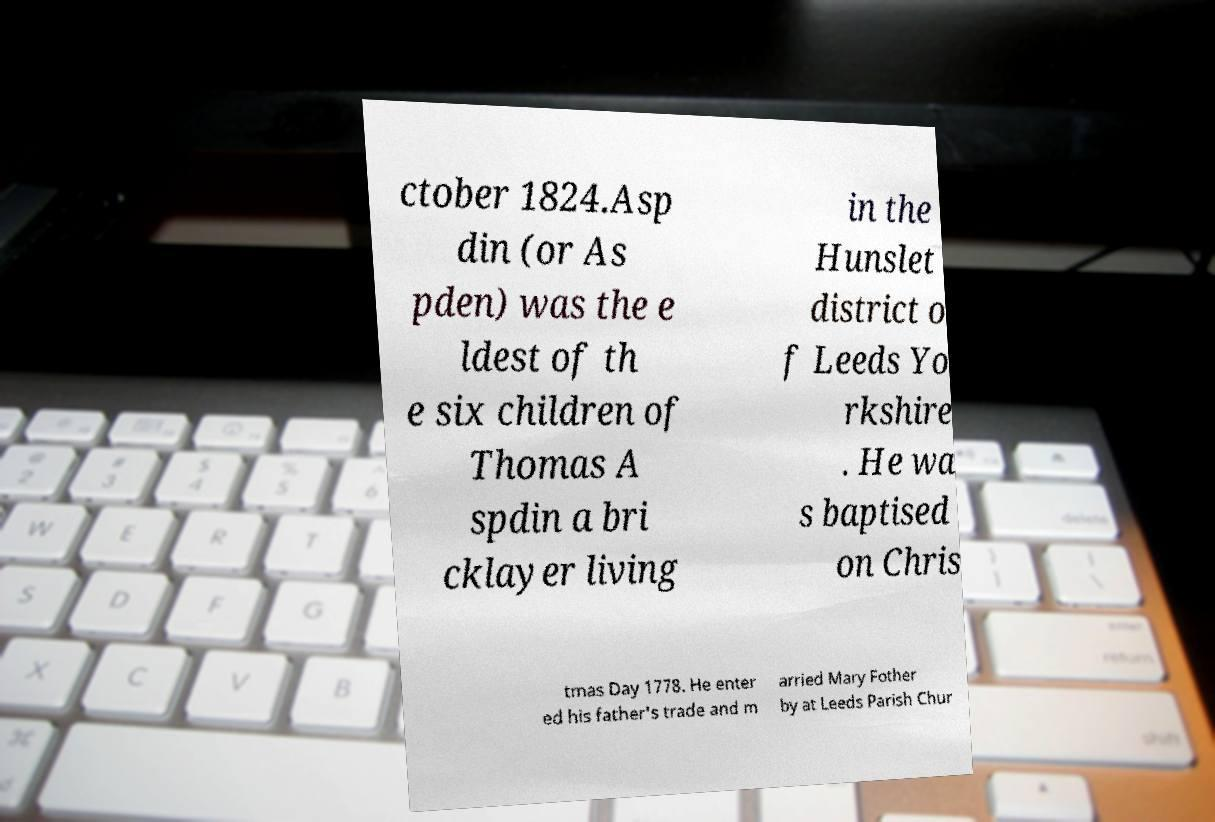For documentation purposes, I need the text within this image transcribed. Could you provide that? ctober 1824.Asp din (or As pden) was the e ldest of th e six children of Thomas A spdin a bri cklayer living in the Hunslet district o f Leeds Yo rkshire . He wa s baptised on Chris tmas Day 1778. He enter ed his father's trade and m arried Mary Fother by at Leeds Parish Chur 